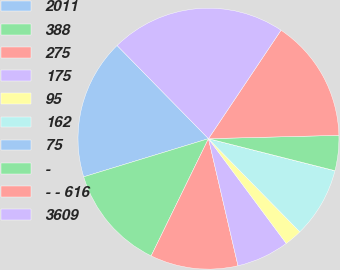<chart> <loc_0><loc_0><loc_500><loc_500><pie_chart><fcel>2011<fcel>388<fcel>275<fcel>175<fcel>95<fcel>162<fcel>75<fcel>-<fcel>- - 616<fcel>3609<nl><fcel>17.38%<fcel>13.04%<fcel>10.87%<fcel>6.53%<fcel>2.18%<fcel>8.7%<fcel>0.01%<fcel>4.35%<fcel>15.21%<fcel>21.73%<nl></chart> 